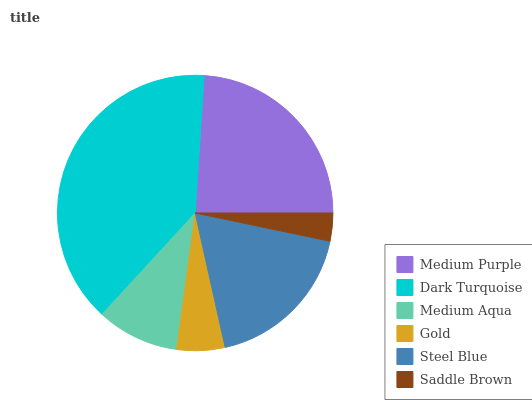Is Saddle Brown the minimum?
Answer yes or no. Yes. Is Dark Turquoise the maximum?
Answer yes or no. Yes. Is Medium Aqua the minimum?
Answer yes or no. No. Is Medium Aqua the maximum?
Answer yes or no. No. Is Dark Turquoise greater than Medium Aqua?
Answer yes or no. Yes. Is Medium Aqua less than Dark Turquoise?
Answer yes or no. Yes. Is Medium Aqua greater than Dark Turquoise?
Answer yes or no. No. Is Dark Turquoise less than Medium Aqua?
Answer yes or no. No. Is Steel Blue the high median?
Answer yes or no. Yes. Is Medium Aqua the low median?
Answer yes or no. Yes. Is Medium Aqua the high median?
Answer yes or no. No. Is Gold the low median?
Answer yes or no. No. 